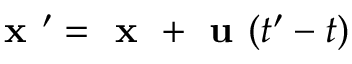Convert formula to latex. <formula><loc_0><loc_0><loc_500><loc_500>x ^ { \prime } = x + u ( t ^ { \prime } - t )</formula> 